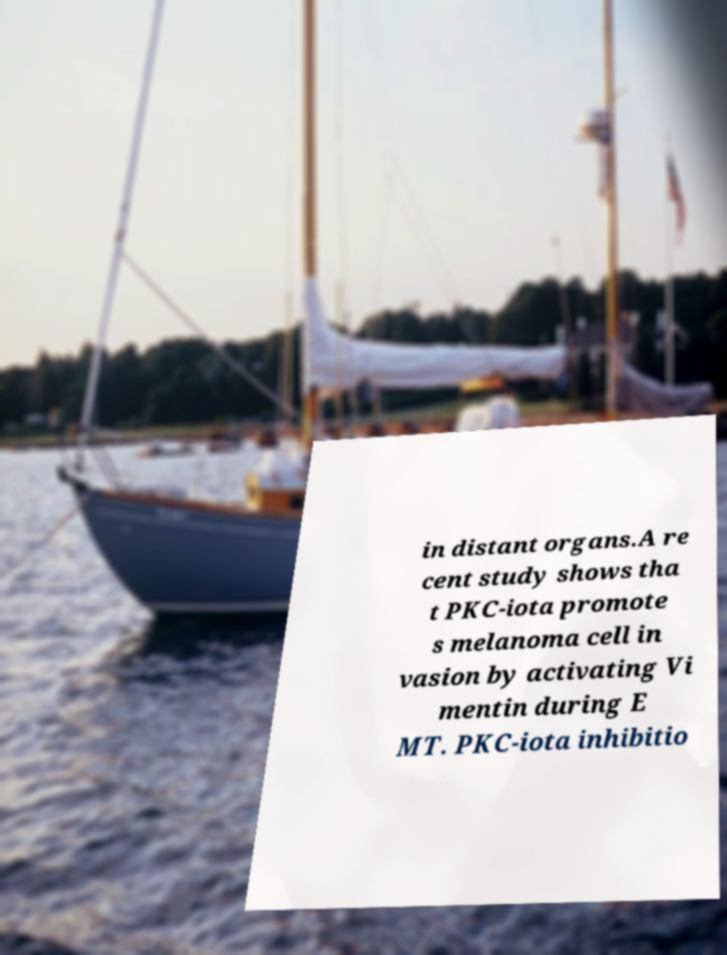Can you read and provide the text displayed in the image?This photo seems to have some interesting text. Can you extract and type it out for me? in distant organs.A re cent study shows tha t PKC-iota promote s melanoma cell in vasion by activating Vi mentin during E MT. PKC-iota inhibitio 